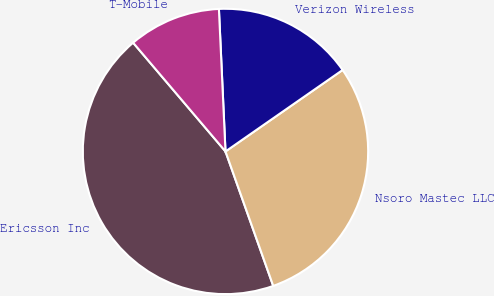Convert chart to OTSL. <chart><loc_0><loc_0><loc_500><loc_500><pie_chart><fcel>Ericsson Inc<fcel>Nsoro Mastec LLC<fcel>Verizon Wireless<fcel>T-Mobile<nl><fcel>44.22%<fcel>29.24%<fcel>16.06%<fcel>10.47%<nl></chart> 